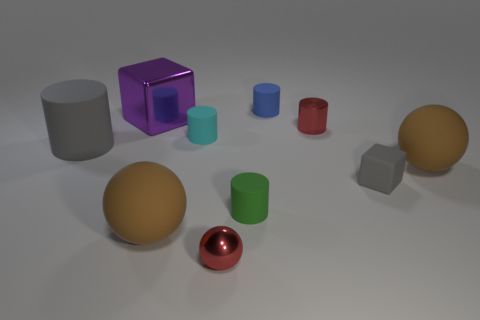Are there the same number of cyan things on the right side of the red cylinder and large spheres?
Make the answer very short. No. What number of objects are both to the left of the red shiny ball and in front of the green thing?
Offer a very short reply. 1. What is the size of the cyan object that is made of the same material as the large cylinder?
Your answer should be very brief. Small. How many tiny green things are the same shape as the small blue object?
Make the answer very short. 1. Are there more tiny green rubber things that are left of the big purple metallic cube than small brown matte things?
Provide a succinct answer. No. The matte object that is in front of the gray cube and to the left of the cyan rubber cylinder has what shape?
Offer a very short reply. Sphere. Do the blue rubber cylinder and the purple thing have the same size?
Ensure brevity in your answer.  No. There is a large shiny cube; how many brown things are behind it?
Ensure brevity in your answer.  0. Are there the same number of big purple metal things in front of the large matte cylinder and red metal balls to the left of the tiny cyan rubber cylinder?
Your answer should be compact. Yes. There is a red object that is behind the cyan cylinder; does it have the same shape as the large gray matte thing?
Provide a short and direct response. Yes. 